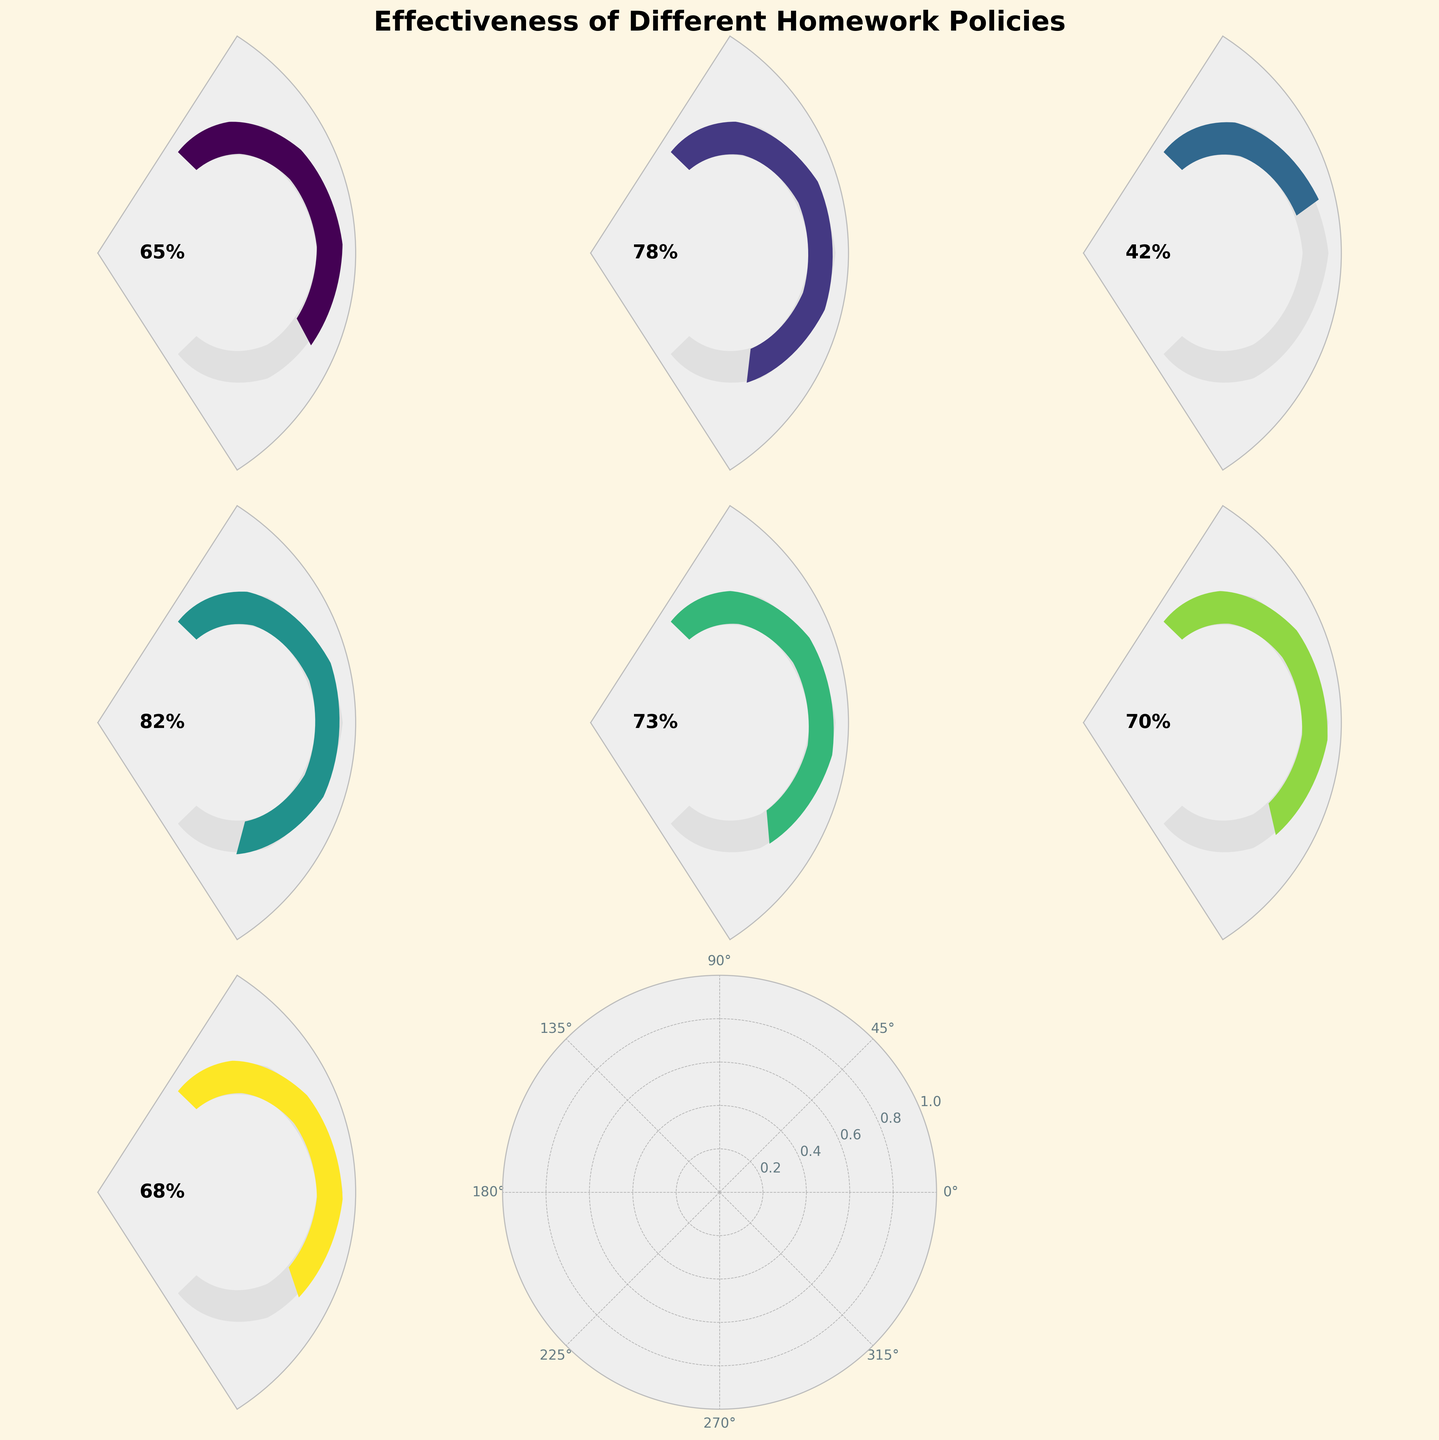What's the title of the figure? The title is located at the top of the figure and states the purpose of the chart, which is to show the effectiveness of different homework policies.
Answer: Effectiveness of Different Homework Policies How many homework policies are depicted in the figure? Each gauge chart corresponds to one homework policy, and the subplots are arranged in a 3x3 grid. Counting the number of filled subplots shows the total policies depicted.
Answer: 7 Which homework policy has the highest effectiveness? By comparing the effectiveness values shown on each gauge, find the maximum value. It’s evident that "Project-based homework" has the highest value of 82%.
Answer: Project-based homework What is the effectiveness percentage of the Flipped classroom approach? Locate the gauge corresponding to the Flipped classroom approach and read the effectiveness percentage displayed on that gauge.
Answer: 73% What is the difference in effectiveness between Daily homework and No homework? Find the effectiveness values for Daily homework (65%) and No homework (42%) and calculate the difference: 65% - 42% = 23%.
Answer: 23% What is the average effectiveness of all the homework policies? Sum up all the effectiveness values and then divide by the number of policies: (65 + 78 + 42 + 82 + 73 + 70 + 68) / 7 = 478 / 7 ≈ 68.3%.
Answer: 68.3% Which homework policies have effectiveness above 70%? Identify the policies and their corresponding effectiveness values. Policies with values above 70% are "Weekly assignments" (78%), "Project-based homework" (82%), "Flipped classroom approach" (73%), and "Differentiated homework" (70%).
Answer: Weekly assignments, Project-based homework, Flipped classroom approach, Differentiated homework Which policy's effectiveness is closest to the average effectiveness of all policies? Calculate the average effectiveness (68.3%) and compare it to each policy’s effectiveness to determine which one is closest: "Collaborative homework" (68%) is closest.
Answer: Collaborative homework What is the median effectiveness of the given homework policies? First, list the effectiveness values in ascending order: 42, 65, 68, 70, 73, 78, 82. The median is the middle value, which is 70.
Answer: 70 Are there more policies with effectiveness above 70% or below 70%? Count the number of policies with effectiveness above 70% (4 policies) and below 70% (3 policies) and compare the counts.
Answer: Above 70% 